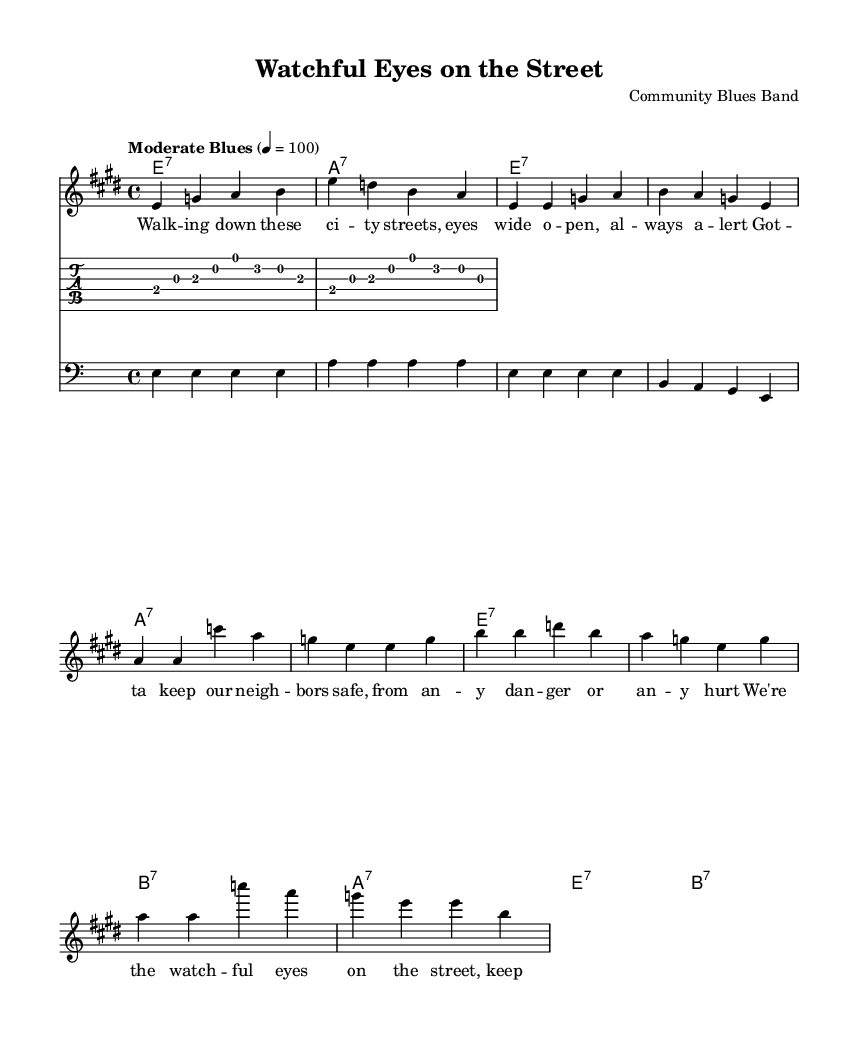What is the key signature of this music? The key signature is E major, which has four sharps: F#, C#, G#, and D#. This can be determined by looking at the key signature indicated at the beginning of the sheet music.
Answer: E major What is the time signature of the piece? The time signature is 4/4, which indicates that there are four beats in a measure and a quarter note gets one beat. This is shown at the beginning of the score.
Answer: 4/4 What is the tempo marking of the piece? The tempo marking is "Moderate Blues," which suggests a relaxed pace typical in blues music. This is noted directly above the staff under the tempo indication.
Answer: Moderate Blues How many measures are in the verse section? To find the number of measures in the verse section, we count the measures in the notation after the intro. There are eight measures in the verse section before the chorus starts.
Answer: Eight What type of chords are mostly used in this piece? The chords used are seventh chords, specifically E7, A7, and B7. This can be inferred from the chord names listed in the harmonies section of the music score.
Answer: Seventh chords How does the melody primarily move? The melody primarily moves by step and small intervals, typical of blues music, allowing for smooth and expressive phrasing. Observing the notes in the melody line reveals this characteristic as the notes progress mostly consecutively with occasional leaps.
Answer: By step What is the main theme of the lyrics? The main theme of the lyrics revolves around community vigilance and urban safety, highlighting the importance of looking out for each other and standing together. This is conveyed through the lyrics provided in the score, which discuss keeping neighbors safe.
Answer: Community vigilance 